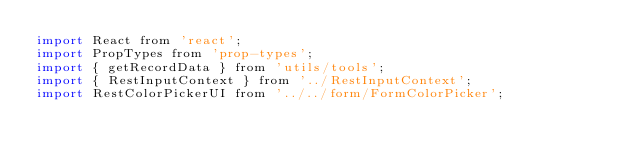Convert code to text. <code><loc_0><loc_0><loc_500><loc_500><_JavaScript_>import React from 'react';
import PropTypes from 'prop-types';
import { getRecordData } from 'utils/tools';
import { RestInputContext } from '../RestInputContext';
import RestColorPickerUI from '../../form/FormColorPicker';
</code> 